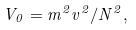Convert formula to latex. <formula><loc_0><loc_0><loc_500><loc_500>V _ { 0 } = m ^ { 2 } v ^ { 2 } / N ^ { 2 } ,</formula> 